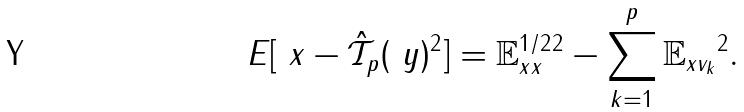Convert formula to latex. <formula><loc_0><loc_0><loc_500><loc_500>E [ \| \ x - \hat { \mathcal { T } } _ { p } ( \ y ) \| ^ { 2 } ] = \| { \mathbb { E } } _ { x x } ^ { 1 / 2 } \| ^ { 2 } - \sum _ { k = 1 } ^ { p } \| { \mathbb { E } } _ { x v _ { k } } \| ^ { 2 } .</formula> 